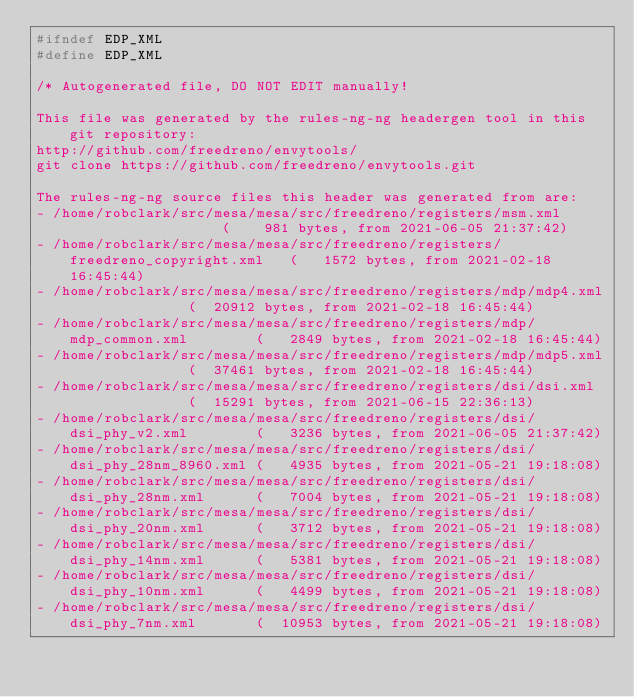<code> <loc_0><loc_0><loc_500><loc_500><_C_>#ifndef EDP_XML
#define EDP_XML

/* Autogenerated file, DO NOT EDIT manually!

This file was generated by the rules-ng-ng headergen tool in this git repository:
http://github.com/freedreno/envytools/
git clone https://github.com/freedreno/envytools.git

The rules-ng-ng source files this header was generated from are:
- /home/robclark/src/mesa/mesa/src/freedreno/registers/msm.xml                   (    981 bytes, from 2021-06-05 21:37:42)
- /home/robclark/src/mesa/mesa/src/freedreno/registers/freedreno_copyright.xml   (   1572 bytes, from 2021-02-18 16:45:44)
- /home/robclark/src/mesa/mesa/src/freedreno/registers/mdp/mdp4.xml              (  20912 bytes, from 2021-02-18 16:45:44)
- /home/robclark/src/mesa/mesa/src/freedreno/registers/mdp/mdp_common.xml        (   2849 bytes, from 2021-02-18 16:45:44)
- /home/robclark/src/mesa/mesa/src/freedreno/registers/mdp/mdp5.xml              (  37461 bytes, from 2021-02-18 16:45:44)
- /home/robclark/src/mesa/mesa/src/freedreno/registers/dsi/dsi.xml               (  15291 bytes, from 2021-06-15 22:36:13)
- /home/robclark/src/mesa/mesa/src/freedreno/registers/dsi/dsi_phy_v2.xml        (   3236 bytes, from 2021-06-05 21:37:42)
- /home/robclark/src/mesa/mesa/src/freedreno/registers/dsi/dsi_phy_28nm_8960.xml (   4935 bytes, from 2021-05-21 19:18:08)
- /home/robclark/src/mesa/mesa/src/freedreno/registers/dsi/dsi_phy_28nm.xml      (   7004 bytes, from 2021-05-21 19:18:08)
- /home/robclark/src/mesa/mesa/src/freedreno/registers/dsi/dsi_phy_20nm.xml      (   3712 bytes, from 2021-05-21 19:18:08)
- /home/robclark/src/mesa/mesa/src/freedreno/registers/dsi/dsi_phy_14nm.xml      (   5381 bytes, from 2021-05-21 19:18:08)
- /home/robclark/src/mesa/mesa/src/freedreno/registers/dsi/dsi_phy_10nm.xml      (   4499 bytes, from 2021-05-21 19:18:08)
- /home/robclark/src/mesa/mesa/src/freedreno/registers/dsi/dsi_phy_7nm.xml       (  10953 bytes, from 2021-05-21 19:18:08)</code> 